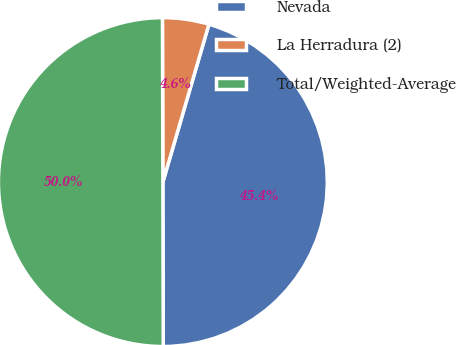Convert chart. <chart><loc_0><loc_0><loc_500><loc_500><pie_chart><fcel>Nevada<fcel>La Herradura (2)<fcel>Total/Weighted-Average<nl><fcel>45.44%<fcel>4.56%<fcel>50.0%<nl></chart> 